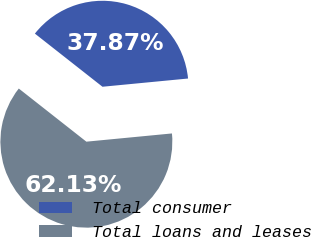Convert chart to OTSL. <chart><loc_0><loc_0><loc_500><loc_500><pie_chart><fcel>Total consumer<fcel>Total loans and leases<nl><fcel>37.87%<fcel>62.13%<nl></chart> 